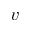Convert formula to latex. <formula><loc_0><loc_0><loc_500><loc_500>v</formula> 